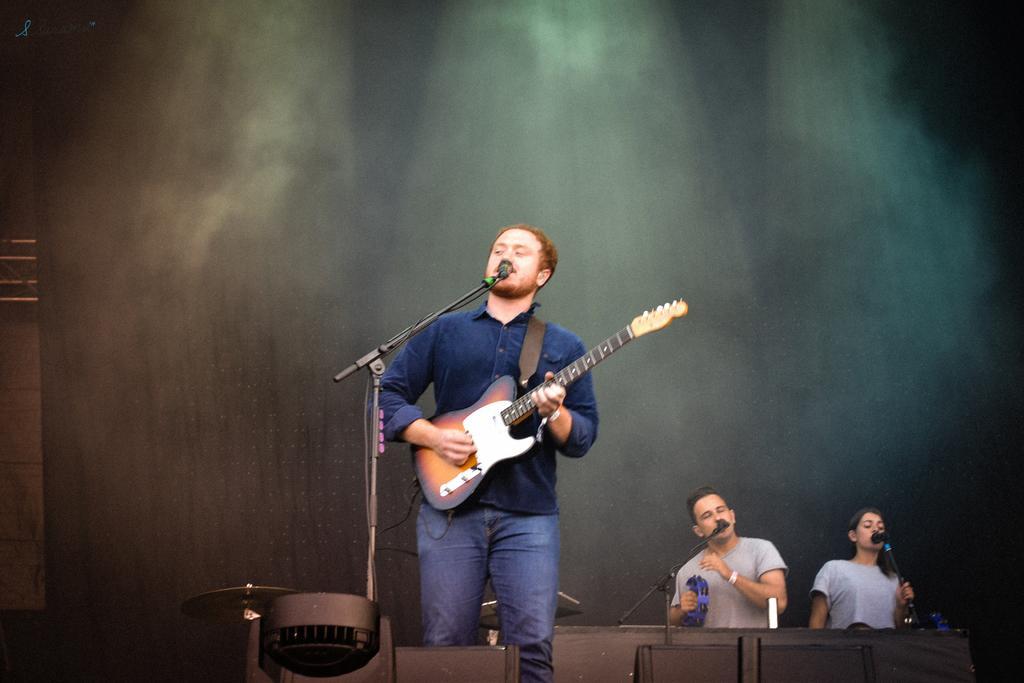Please provide a concise description of this image. A man is standing,playing guitar and also singing in the microphone behind them there is a man and woman. 